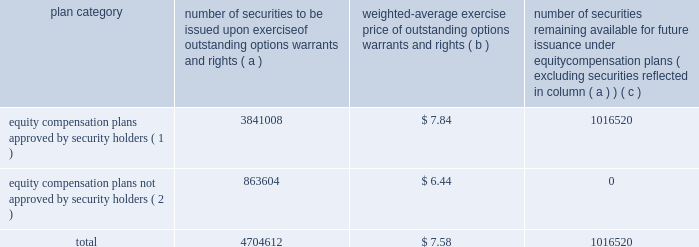Part iii item 10 .
Directors and executive officers of the registrant .
Pursuant to section 406 of the sarbanes-oxley act of 2002 , we have adopted a code of ethics for senior financial officers that applies to our principal executive officer and principal financial officer , principal accounting officer and controller , and other persons performing similar functions .
Our code of ethics for senior financial officers is publicly available on our website at www.hologic.com .
We intend to satisfy the disclosure requirement under item 5.05 of current report on form 8-k regarding an amendment to , or waiver from , a provision of this code by posting such information on our website , at the address specified above .
The additional information required by this item is incorporated by reference to our definitive proxy statement for our annual meeting of stockholders to be filed with the securities and exchange commission within 120 days after the close of our fiscal year .
Item 11 .
Executive compensation .
The information required by this item is incorporated by reference to our definitive proxy statement for our annual meeting of stockholders to be filed with the securities and exchange commission within 120 days after the close of our fiscal year .
Item 12 .
Security ownership of certain beneficial owners and management and related stockholder matters .
We maintain a number of equity compensation plans for employees , officers , directors and others whose efforts contribute to our success .
The table below sets forth certain information as our fiscal year ended september 24 , 2005 regarding the shares of our common stock available for grant or granted under stock option plans that ( i ) were approved by our stockholders , and ( ii ) were not approved by our stockholders .
The number of securities and the exercise price of the outstanding securities have been adjusted to reflect our two-for-one stock split effected on november 30 , 2005 .
Equity compensation plan information plan category number of securities to be issued upon exercise of outstanding options , warrants and rights weighted-average exercise price of outstanding options , warrants and rights number of securities remaining available for future issuance under equity compensation plans ( excluding securities reflected in column ( a ) ) equity compensation plans approved by security holders ( 1 ) .
3841008 $ 7.84 1016520 equity compensation plans not approved by security holders ( 2 ) .
863604 $ 6.44 0 .
( 1 ) includes the following plans : 1986 combination stock option plan ; amended and restated 1990 non-employee director stock option plan ; 1995 combination stock option plan ; amended and restated 1999 equity incentive plan ; and 2000 employee stock purchase plan .
Also includes the following plans which we assumed in connection with our acquisition of fluoroscan imaging systems in 1996 : fluoroscan imaging systems , inc .
1994 amended and restated stock incentive plan and fluoroscan imaging systems , inc .
1995 stock incentive plan .
For a description of these plans , please refer to footnote 5 contained in our consolidated financial statements. .
What portion of the total number of issues securities is approved by security holders? 
Computations: (3841008 / 4704612)
Answer: 0.81643. 